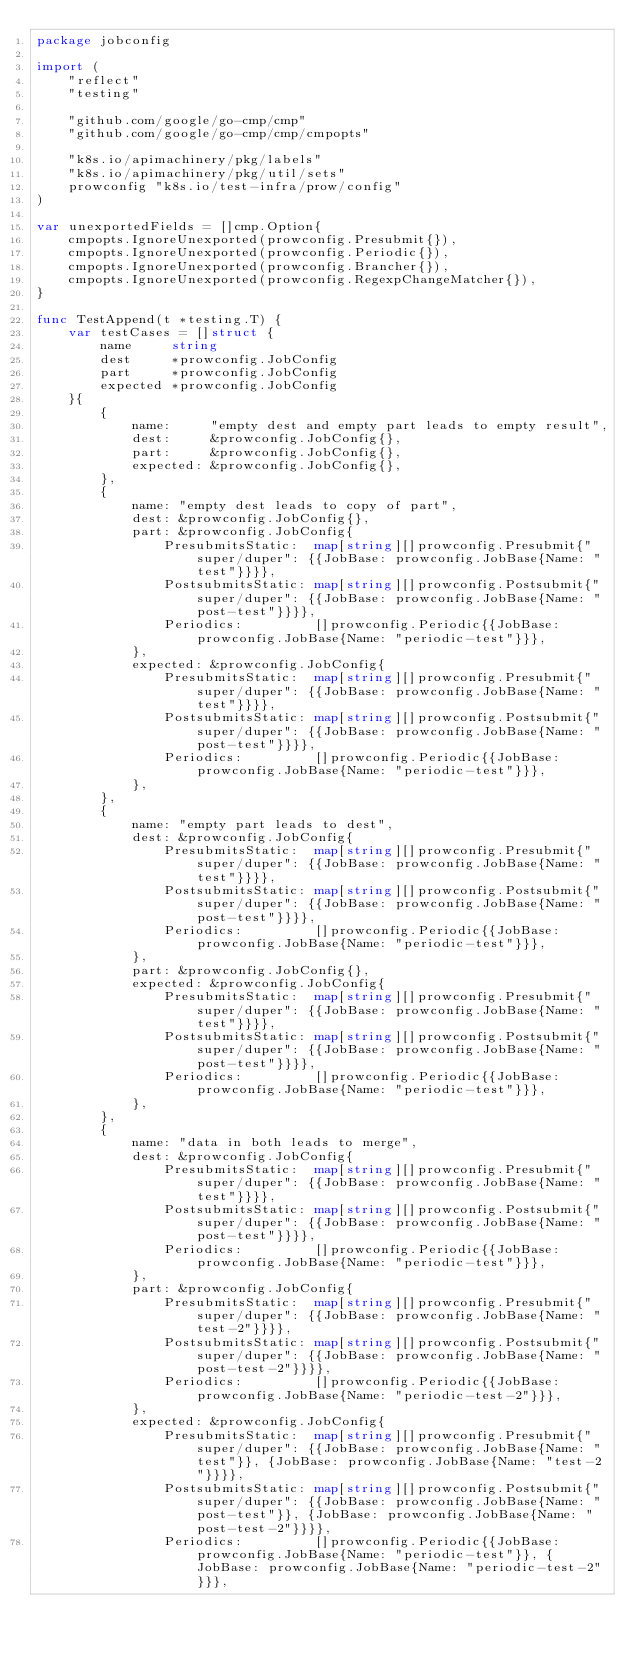Convert code to text. <code><loc_0><loc_0><loc_500><loc_500><_Go_>package jobconfig

import (
	"reflect"
	"testing"

	"github.com/google/go-cmp/cmp"
	"github.com/google/go-cmp/cmp/cmpopts"

	"k8s.io/apimachinery/pkg/labels"
	"k8s.io/apimachinery/pkg/util/sets"
	prowconfig "k8s.io/test-infra/prow/config"
)

var unexportedFields = []cmp.Option{
	cmpopts.IgnoreUnexported(prowconfig.Presubmit{}),
	cmpopts.IgnoreUnexported(prowconfig.Periodic{}),
	cmpopts.IgnoreUnexported(prowconfig.Brancher{}),
	cmpopts.IgnoreUnexported(prowconfig.RegexpChangeMatcher{}),
}

func TestAppend(t *testing.T) {
	var testCases = []struct {
		name     string
		dest     *prowconfig.JobConfig
		part     *prowconfig.JobConfig
		expected *prowconfig.JobConfig
	}{
		{
			name:     "empty dest and empty part leads to empty result",
			dest:     &prowconfig.JobConfig{},
			part:     &prowconfig.JobConfig{},
			expected: &prowconfig.JobConfig{},
		},
		{
			name: "empty dest leads to copy of part",
			dest: &prowconfig.JobConfig{},
			part: &prowconfig.JobConfig{
				PresubmitsStatic:  map[string][]prowconfig.Presubmit{"super/duper": {{JobBase: prowconfig.JobBase{Name: "test"}}}},
				PostsubmitsStatic: map[string][]prowconfig.Postsubmit{"super/duper": {{JobBase: prowconfig.JobBase{Name: "post-test"}}}},
				Periodics:         []prowconfig.Periodic{{JobBase: prowconfig.JobBase{Name: "periodic-test"}}},
			},
			expected: &prowconfig.JobConfig{
				PresubmitsStatic:  map[string][]prowconfig.Presubmit{"super/duper": {{JobBase: prowconfig.JobBase{Name: "test"}}}},
				PostsubmitsStatic: map[string][]prowconfig.Postsubmit{"super/duper": {{JobBase: prowconfig.JobBase{Name: "post-test"}}}},
				Periodics:         []prowconfig.Periodic{{JobBase: prowconfig.JobBase{Name: "periodic-test"}}},
			},
		},
		{
			name: "empty part leads to dest",
			dest: &prowconfig.JobConfig{
				PresubmitsStatic:  map[string][]prowconfig.Presubmit{"super/duper": {{JobBase: prowconfig.JobBase{Name: "test"}}}},
				PostsubmitsStatic: map[string][]prowconfig.Postsubmit{"super/duper": {{JobBase: prowconfig.JobBase{Name: "post-test"}}}},
				Periodics:         []prowconfig.Periodic{{JobBase: prowconfig.JobBase{Name: "periodic-test"}}},
			},
			part: &prowconfig.JobConfig{},
			expected: &prowconfig.JobConfig{
				PresubmitsStatic:  map[string][]prowconfig.Presubmit{"super/duper": {{JobBase: prowconfig.JobBase{Name: "test"}}}},
				PostsubmitsStatic: map[string][]prowconfig.Postsubmit{"super/duper": {{JobBase: prowconfig.JobBase{Name: "post-test"}}}},
				Periodics:         []prowconfig.Periodic{{JobBase: prowconfig.JobBase{Name: "periodic-test"}}},
			},
		},
		{
			name: "data in both leads to merge",
			dest: &prowconfig.JobConfig{
				PresubmitsStatic:  map[string][]prowconfig.Presubmit{"super/duper": {{JobBase: prowconfig.JobBase{Name: "test"}}}},
				PostsubmitsStatic: map[string][]prowconfig.Postsubmit{"super/duper": {{JobBase: prowconfig.JobBase{Name: "post-test"}}}},
				Periodics:         []prowconfig.Periodic{{JobBase: prowconfig.JobBase{Name: "periodic-test"}}},
			},
			part: &prowconfig.JobConfig{
				PresubmitsStatic:  map[string][]prowconfig.Presubmit{"super/duper": {{JobBase: prowconfig.JobBase{Name: "test-2"}}}},
				PostsubmitsStatic: map[string][]prowconfig.Postsubmit{"super/duper": {{JobBase: prowconfig.JobBase{Name: "post-test-2"}}}},
				Periodics:         []prowconfig.Periodic{{JobBase: prowconfig.JobBase{Name: "periodic-test-2"}}},
			},
			expected: &prowconfig.JobConfig{
				PresubmitsStatic:  map[string][]prowconfig.Presubmit{"super/duper": {{JobBase: prowconfig.JobBase{Name: "test"}}, {JobBase: prowconfig.JobBase{Name: "test-2"}}}},
				PostsubmitsStatic: map[string][]prowconfig.Postsubmit{"super/duper": {{JobBase: prowconfig.JobBase{Name: "post-test"}}, {JobBase: prowconfig.JobBase{Name: "post-test-2"}}}},
				Periodics:         []prowconfig.Periodic{{JobBase: prowconfig.JobBase{Name: "periodic-test"}}, {JobBase: prowconfig.JobBase{Name: "periodic-test-2"}}},</code> 